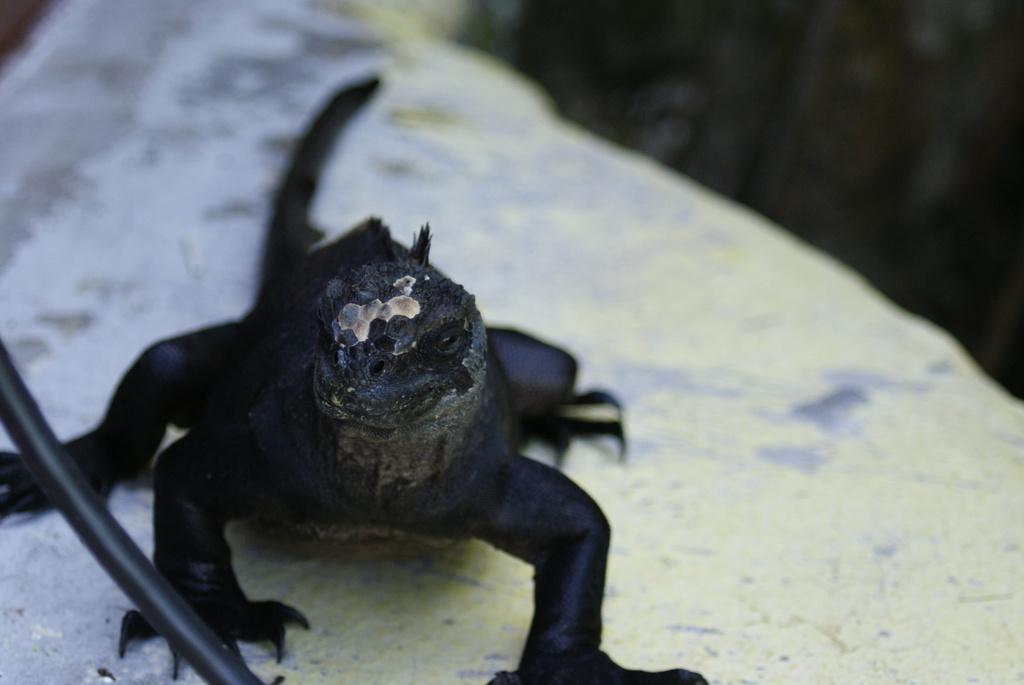In one or two sentences, can you explain what this image depicts? In this picture we can see a black color reptile. 